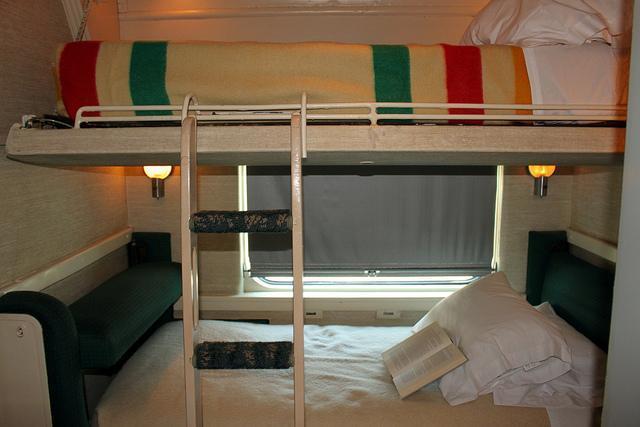How many steps does it take to get to the top?
Give a very brief answer. 2. How many beds can you see?
Give a very brief answer. 2. 